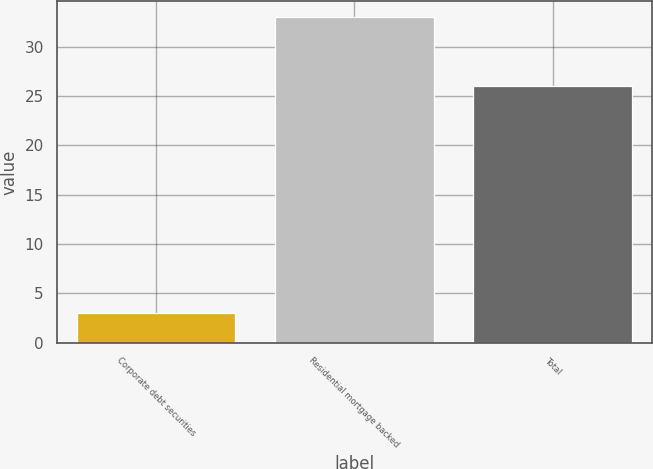Convert chart. <chart><loc_0><loc_0><loc_500><loc_500><bar_chart><fcel>Corporate debt securities<fcel>Residential mortgage backed<fcel>Total<nl><fcel>3<fcel>33<fcel>26<nl></chart> 